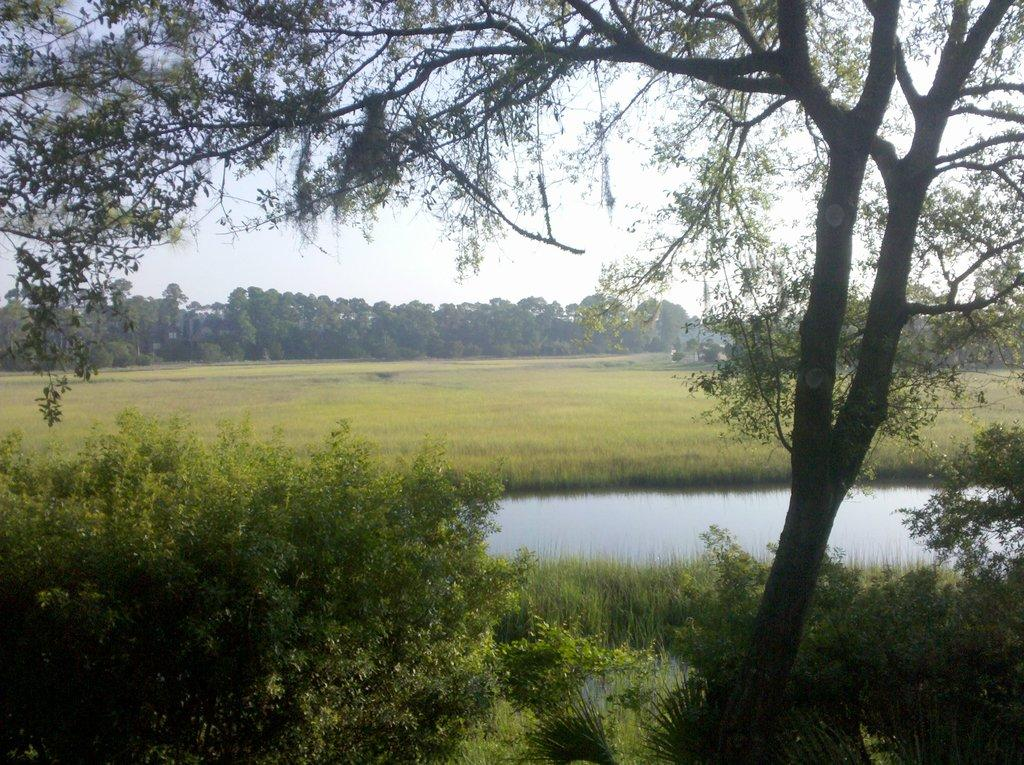What type of vegetation can be seen in the image? There are trees in the image. What part of the natural environment is visible in the image? The sky is visible in the image. What body of water is present in the image? There is a lake in the image. What type of songs can be heard coming from the lake in the image? There is no indication in the image that songs are being played or heard, as the image only shows trees, the sky, and a lake. 